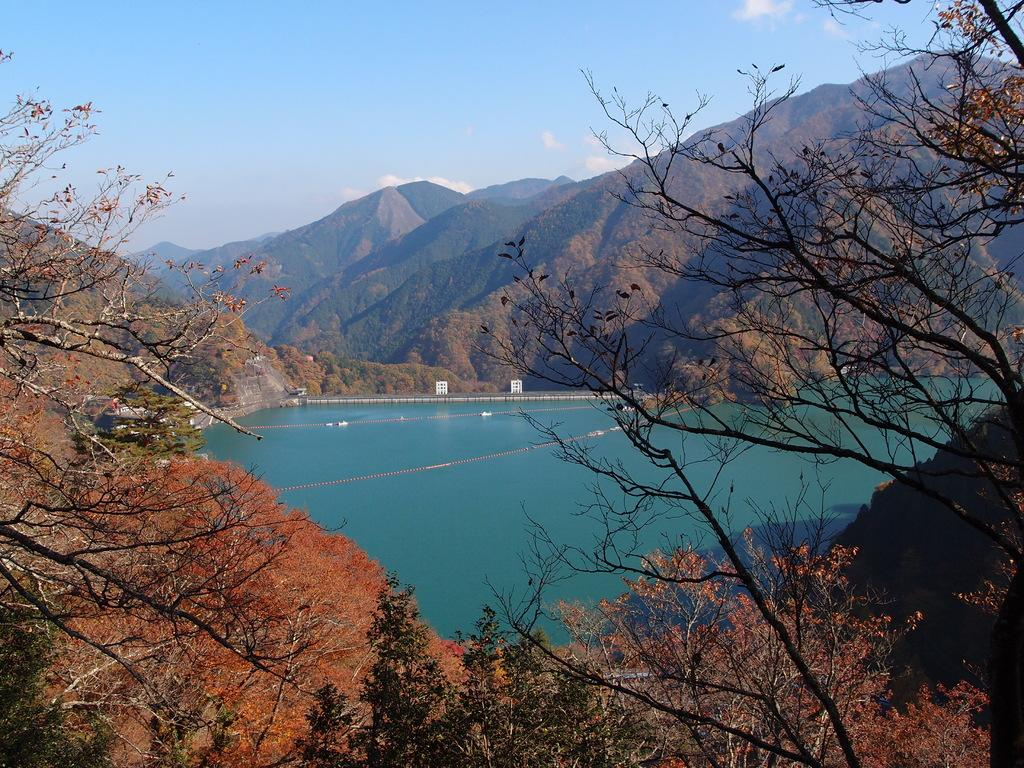What type of natural elements can be seen in the image? There are trees and hills visible in the image. What else can be seen in the image besides the trees and hills? There is water visible in the image. What part of the natural environment is visible in the image? The sky is visible in the image. What type of stone is being used to build the toys in the image? There are no toys or stone present in the image. Can you describe the group of people interacting with the stone in the image? There is no group of people or stone present in the image. 